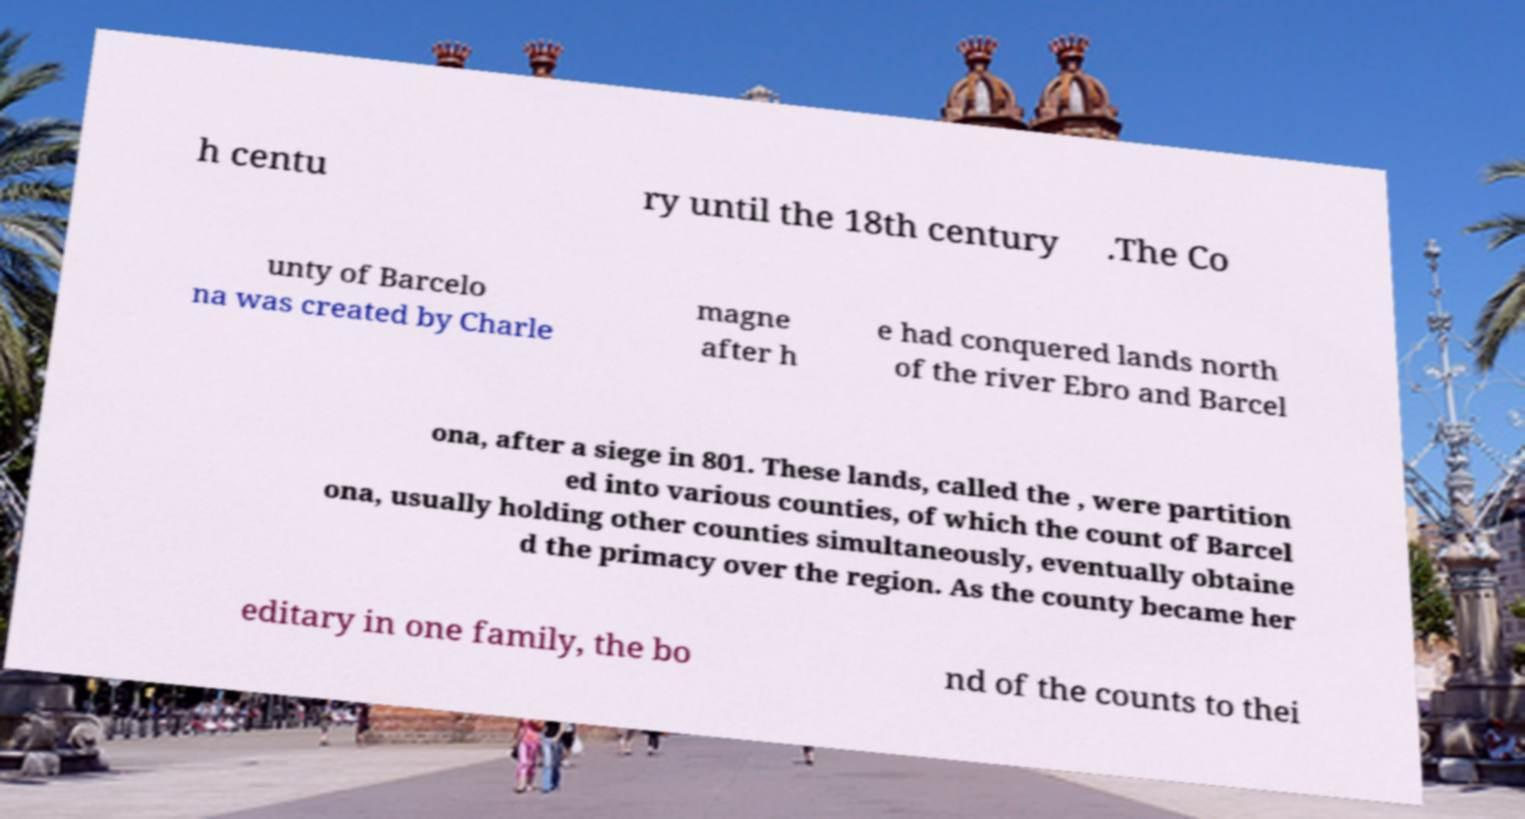Can you accurately transcribe the text from the provided image for me? h centu ry until the 18th century .The Co unty of Barcelo na was created by Charle magne after h e had conquered lands north of the river Ebro and Barcel ona, after a siege in 801. These lands, called the , were partition ed into various counties, of which the count of Barcel ona, usually holding other counties simultaneously, eventually obtaine d the primacy over the region. As the county became her editary in one family, the bo nd of the counts to thei 